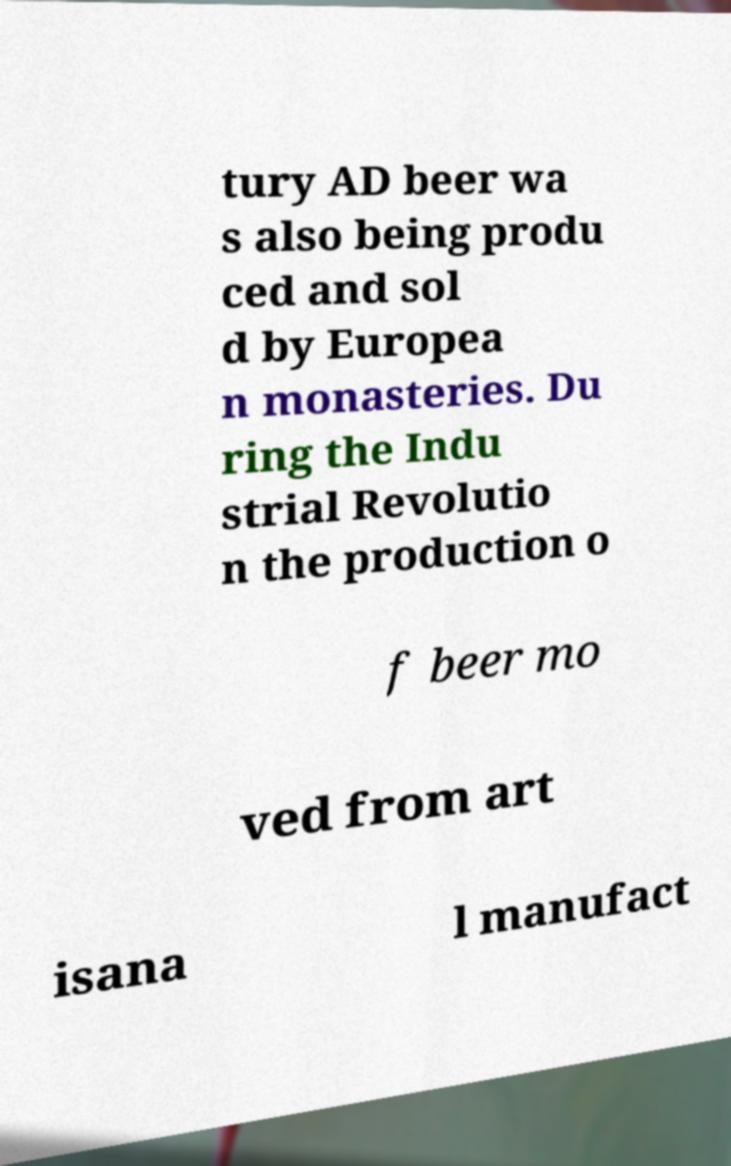What messages or text are displayed in this image? I need them in a readable, typed format. tury AD beer wa s also being produ ced and sol d by Europea n monasteries. Du ring the Indu strial Revolutio n the production o f beer mo ved from art isana l manufact 